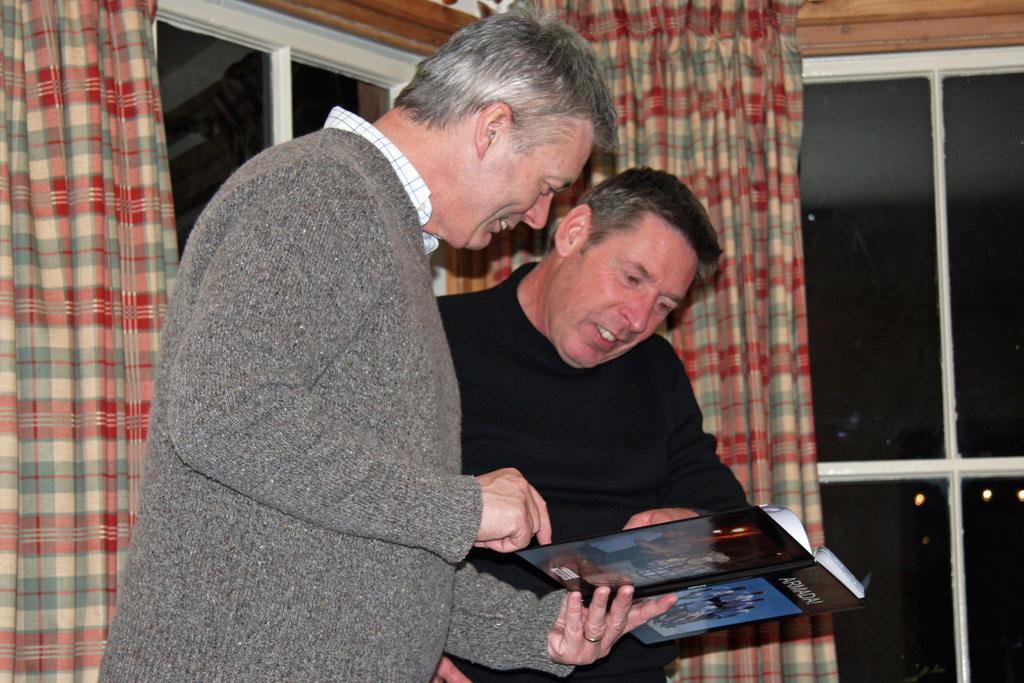Can you describe this image briefly? In this image I can see two people with different color dresses. I can see one person is holding an object. In the background I can see the curtains to the windows. 